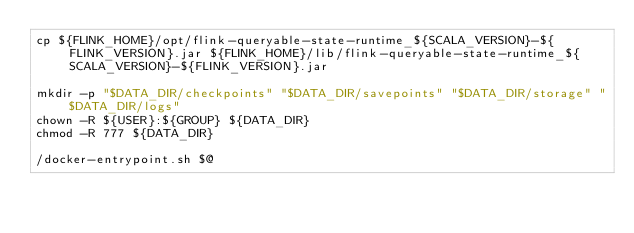<code> <loc_0><loc_0><loc_500><loc_500><_Bash_>cp ${FLINK_HOME}/opt/flink-queryable-state-runtime_${SCALA_VERSION}-${FLINK_VERSION}.jar ${FLINK_HOME}/lib/flink-queryable-state-runtime_${SCALA_VERSION}-${FLINK_VERSION}.jar

mkdir -p "$DATA_DIR/checkpoints" "$DATA_DIR/savepoints" "$DATA_DIR/storage" "$DATA_DIR/logs"
chown -R ${USER}:${GROUP} ${DATA_DIR}
chmod -R 777 ${DATA_DIR}

/docker-entrypoint.sh $@
</code> 